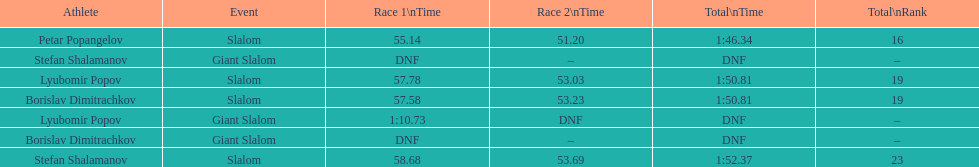Which athlete finished the first race but did not finish the second race? Lyubomir Popov. 